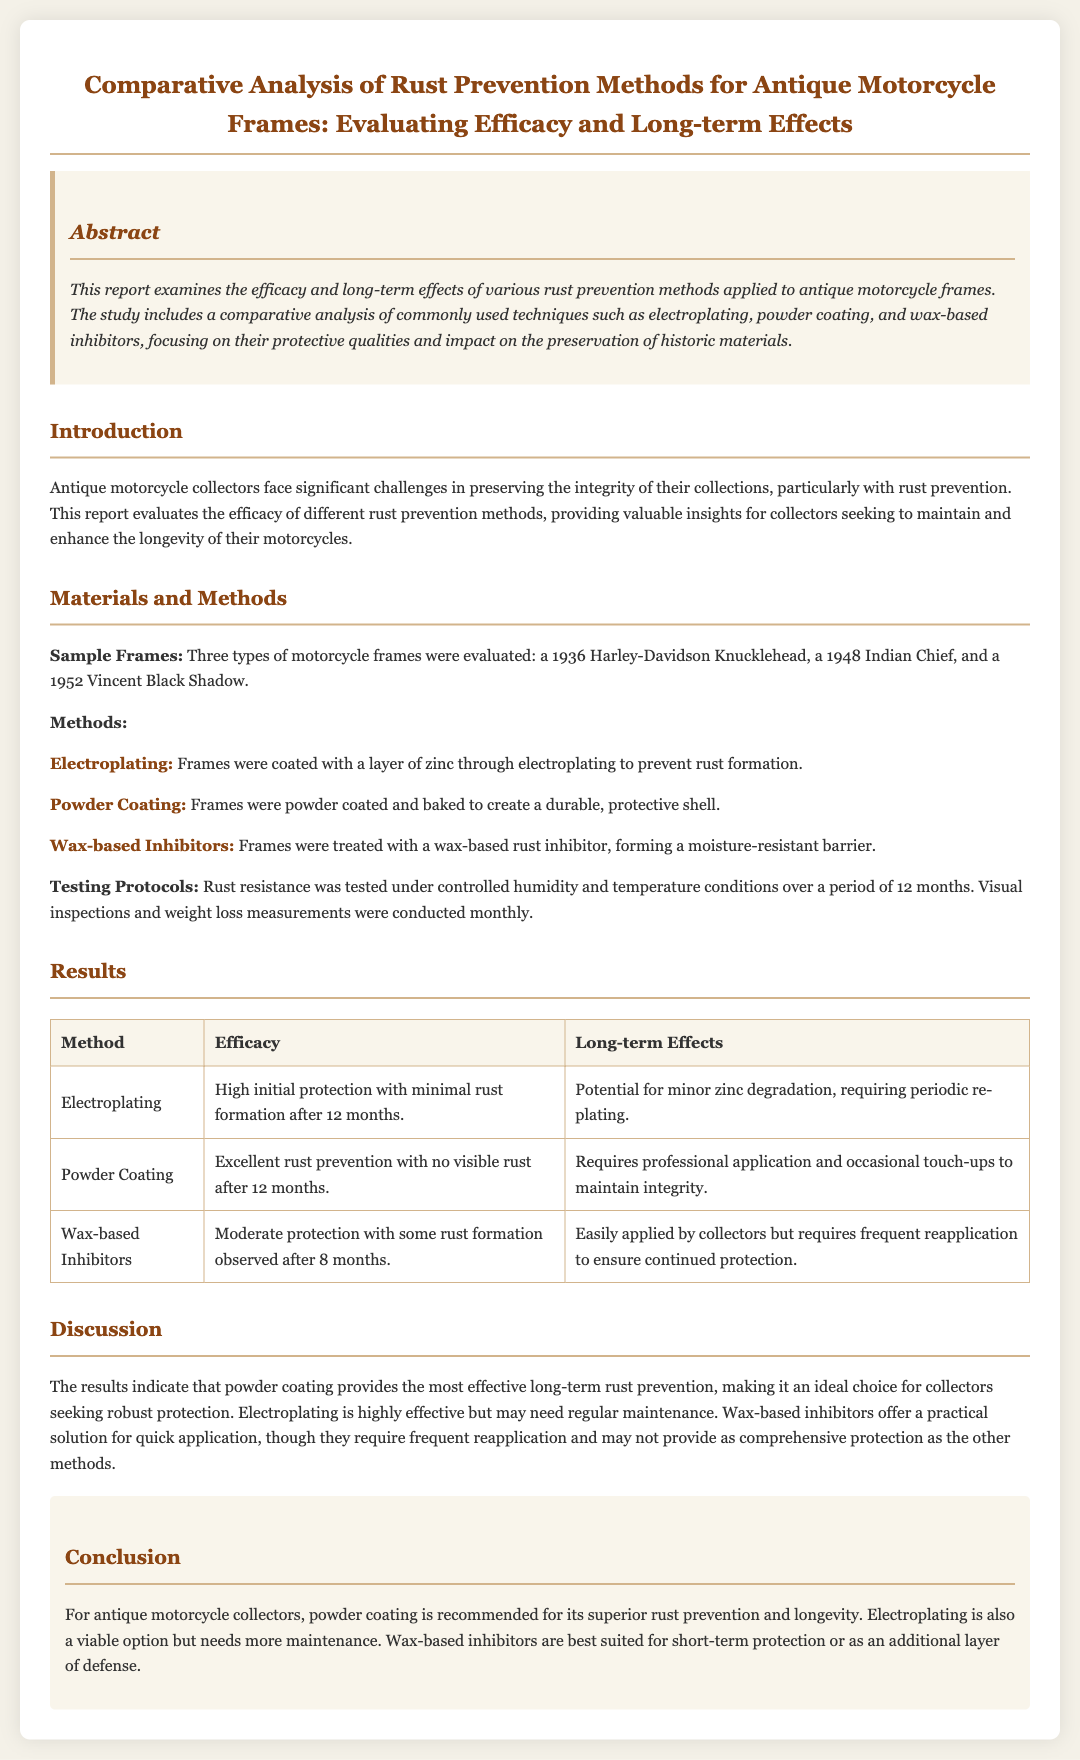what is the main focus of the report? The report examines the efficacy and long-term effects of various rust prevention methods applied to antique motorcycle frames.
Answer: rust prevention methods how many types of motorcycle frames were evaluated? Three types of motorcycle frames were evaluated in this study.
Answer: three which rust prevention method showed no visible rust after 12 months? The method providing excellent rust prevention with no visible rust after 12 months.
Answer: Powder Coating what are the three rust prevention methods discussed? The report details three rust prevention methods used on the motorcycle frames.
Answer: Electroplating, Powder Coating, Wax-based Inhibitors what is a potential issue with electroplating mentioned in the results? The results indicate a potential issue regarding electroplating.
Answer: minor zinc degradation which method requires professional application? One of the rust prevention methods is noted for requiring professional application.
Answer: Powder Coating what is recommended for collectors seeking robust protection? The conclusion suggests the best option for collectors needing robust protection.
Answer: powder coating how often do wax-based inhibitors require reapplication? Wax-based inhibitors have a certain frequency of required reapplication for effective protection.
Answer: frequent 